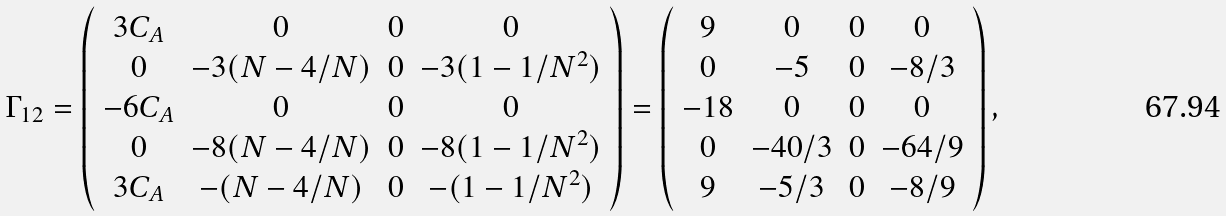Convert formula to latex. <formula><loc_0><loc_0><loc_500><loc_500>\Gamma _ { 1 2 } = \left ( \begin{array} { c c c c } 3 C _ { A } & 0 & 0 & 0 \\ 0 & - 3 ( N - 4 / N ) & 0 & - 3 ( 1 - 1 / N ^ { 2 } ) \\ - 6 C _ { A } & 0 & 0 & 0 \\ 0 & - 8 ( N - 4 / N ) & 0 & - 8 ( 1 - 1 / N ^ { 2 } ) \\ 3 C _ { A } & - ( N - 4 / N ) & 0 & - ( 1 - 1 / N ^ { 2 } ) \\ \end{array} \right ) = \left ( \begin{array} { c c c c } 9 & 0 & 0 & 0 \\ 0 & - 5 & 0 & - { 8 } / { 3 } \\ - 1 8 & 0 & 0 & 0 \\ 0 & - { 4 0 } / { 3 } & 0 & - { 6 4 } / { 9 } \\ 9 & - { 5 } / { 3 } & 0 & - { 8 } / { 9 } \\ \end{array} \right ) ,</formula> 